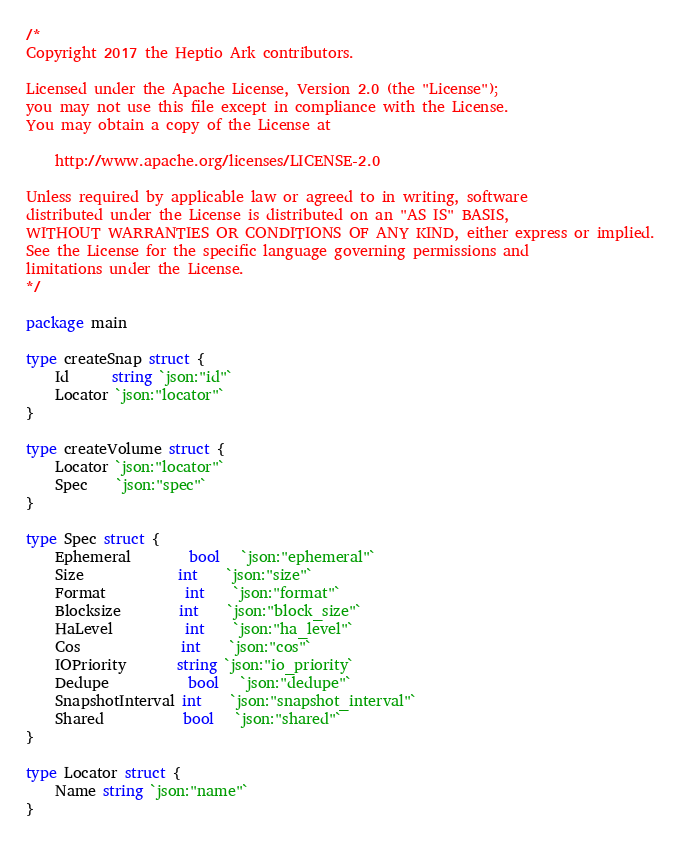<code> <loc_0><loc_0><loc_500><loc_500><_Go_>/*
Copyright 2017 the Heptio Ark contributors.

Licensed under the Apache License, Version 2.0 (the "License");
you may not use this file except in compliance with the License.
You may obtain a copy of the License at

    http://www.apache.org/licenses/LICENSE-2.0

Unless required by applicable law or agreed to in writing, software
distributed under the License is distributed on an "AS IS" BASIS,
WITHOUT WARRANTIES OR CONDITIONS OF ANY KIND, either express or implied.
See the License for the specific language governing permissions and
limitations under the License.
*/

package main

type createSnap struct {
	Id      string `json:"id"`
	Locator `json:"locator"`
}

type createVolume struct {
	Locator `json:"locator"`
	Spec    `json:"spec"`
}

type Spec struct {
	Ephemeral        bool   `json:"ephemeral"`
	Size             int    `json:"size"`
	Format           int    `json:"format"`
	Blocksize        int    `json:"block_size"`
	HaLevel          int    `json:"ha_level"`
	Cos              int    `json:"cos"`
	IOPriority       string `json:"io_priority`
	Dedupe           bool   `json:"dedupe"`
	SnapshotInterval int    `json:"snapshot_interval"`
	Shared           bool   `json:"shared"`
}

type Locator struct {
	Name string `json:"name"`
}
</code> 